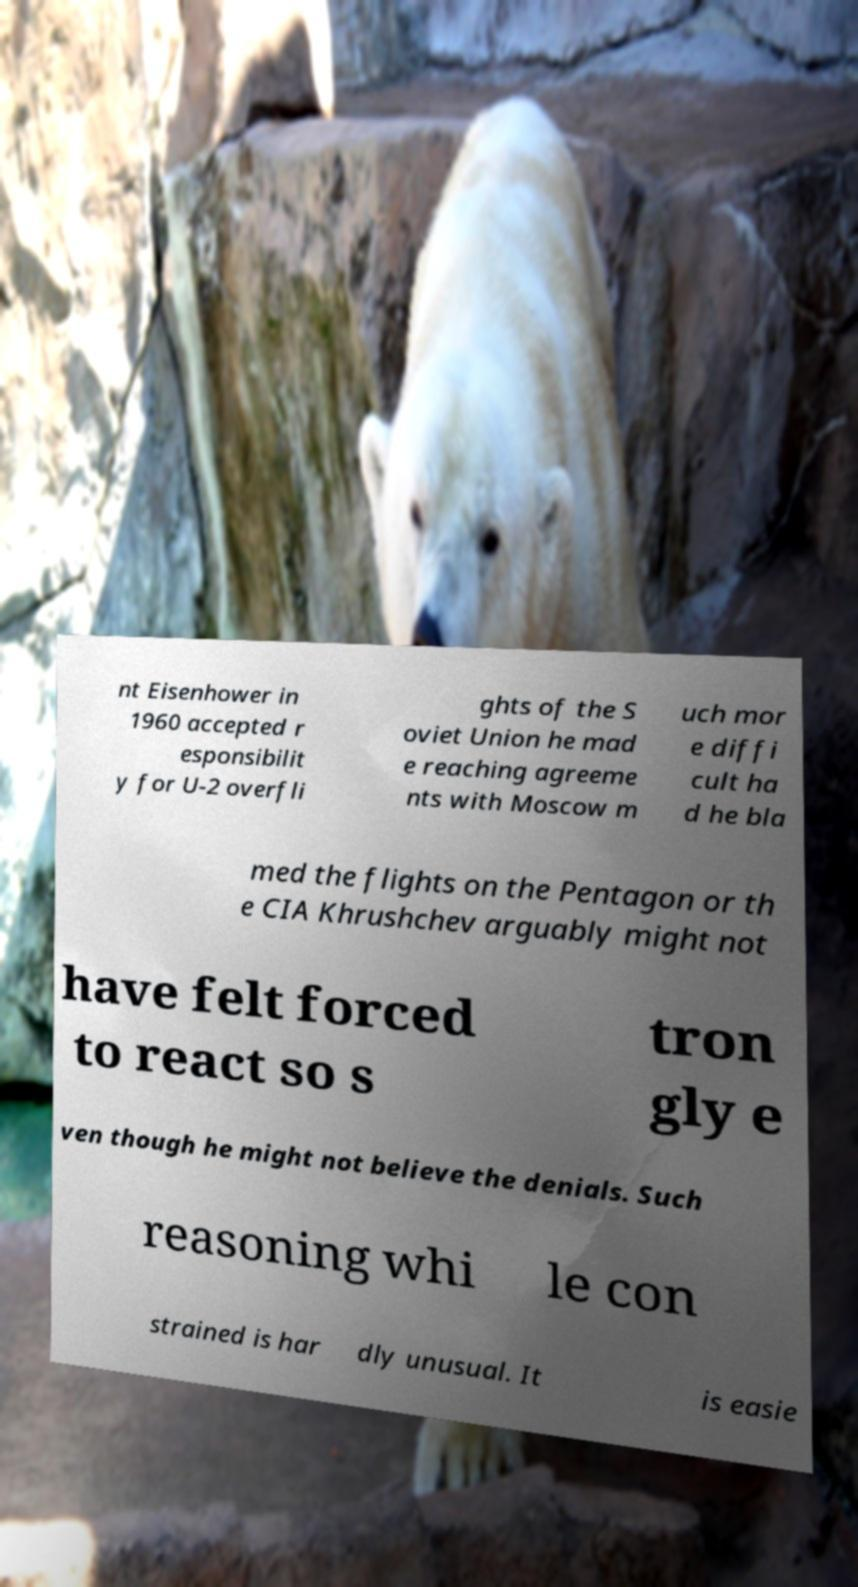Please identify and transcribe the text found in this image. nt Eisenhower in 1960 accepted r esponsibilit y for U-2 overfli ghts of the S oviet Union he mad e reaching agreeme nts with Moscow m uch mor e diffi cult ha d he bla med the flights on the Pentagon or th e CIA Khrushchev arguably might not have felt forced to react so s tron gly e ven though he might not believe the denials. Such reasoning whi le con strained is har dly unusual. It is easie 